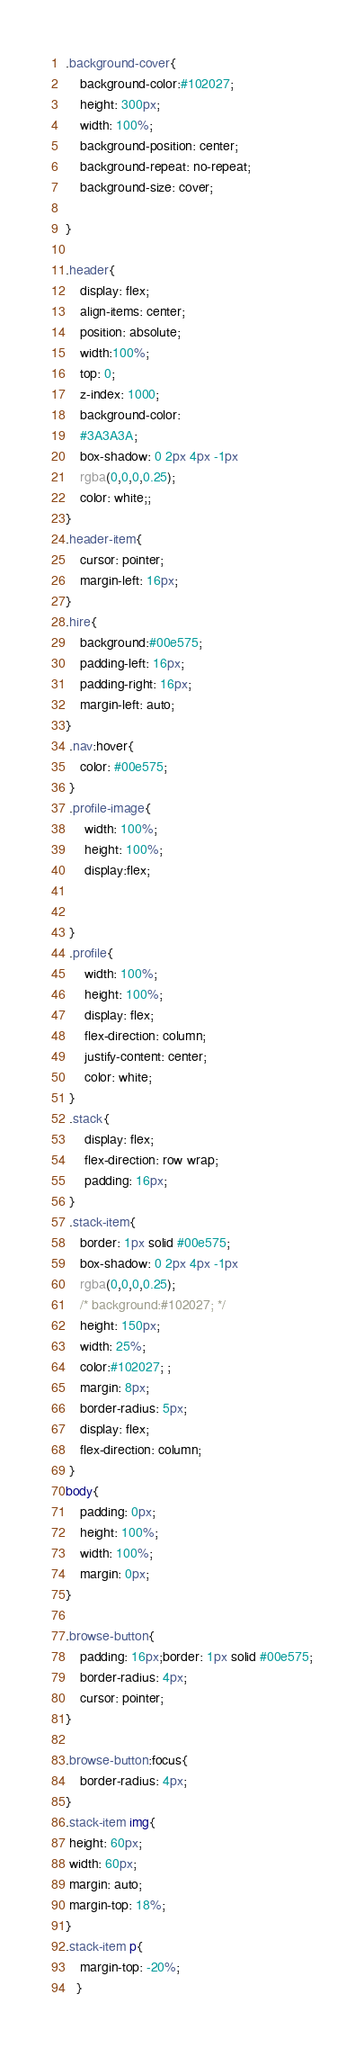Convert code to text. <code><loc_0><loc_0><loc_500><loc_500><_CSS_>.background-cover{
    background-color:#102027;
    height: 300px;
    width: 100%;
    background-position: center;
    background-repeat: no-repeat;
    background-size: cover;
    
}

.header{
    display: flex;
    align-items: center;
    position: absolute;
    width:100%;
    top: 0;
    z-index: 1000;
    background-color:
    #3A3A3A;
    box-shadow: 0 2px 4px -1px
    rgba(0,0,0,0.25);
    color: white;;
}
.header-item{
    cursor: pointer;
    margin-left: 16px;
}
.hire{
    background:#00e575;
    padding-left: 16px;
    padding-right: 16px;
    margin-left: auto;
}
 .nav:hover{
    color: #00e575;
 }
 .profile-image{
     width: 100%;
     height: 100%;
     display:flex;
     
    
 }
 .profile{
     width: 100%;
     height: 100%;
     display: flex;
     flex-direction: column;
     justify-content: center;
     color: white;
 }
 .stack{
     display: flex;
     flex-direction: row wrap;
     padding: 16px;
 }
 .stack-item{
    border: 1px solid #00e575;
    box-shadow: 0 2px 4px -1px
    rgba(0,0,0,0.25);
    /* background:#102027; */
    height: 150px;
    width: 25%;
    color:#102027; ;
    margin: 8px;
    border-radius: 5px;
    display: flex;
    flex-direction: column;
 }
body{
    padding: 0px;
    height: 100%;
    width: 100%;
    margin: 0px;
}

.browse-button{
    padding: 16px;border: 1px solid #00e575;
    border-radius: 4px;
    cursor: pointer;
}

.browse-button:focus{
    border-radius: 4px;
}
.stack-item img{
 height: 60px;
 width: 60px;
 margin: auto;
 margin-top: 18%;
}
.stack-item p{
    margin-top: -20%;
   }</code> 